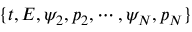Convert formula to latex. <formula><loc_0><loc_0><loc_500><loc_500>\{ t , E , \psi _ { 2 } , p _ { 2 } , \cdots , \psi _ { N } , p _ { N } \}</formula> 